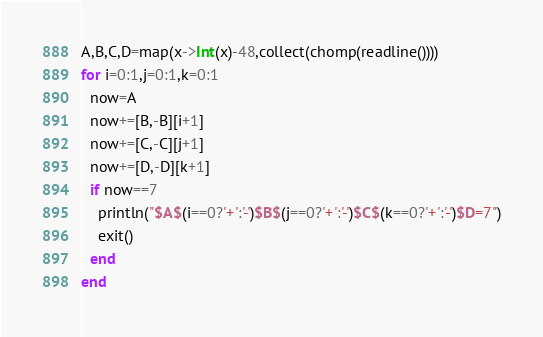Convert code to text. <code><loc_0><loc_0><loc_500><loc_500><_Julia_>A,B,C,D=map(x->Int(x)-48,collect(chomp(readline())))
for i=0:1,j=0:1,k=0:1
  now=A
  now+=[B,-B][i+1]
  now+=[C,-C][j+1]
  now+=[D,-D][k+1]
  if now==7
    println("$A$(i==0?'+':'-')$B$(j==0?'+':'-')$C$(k==0?'+':'-')$D=7")
    exit()
  end
end</code> 